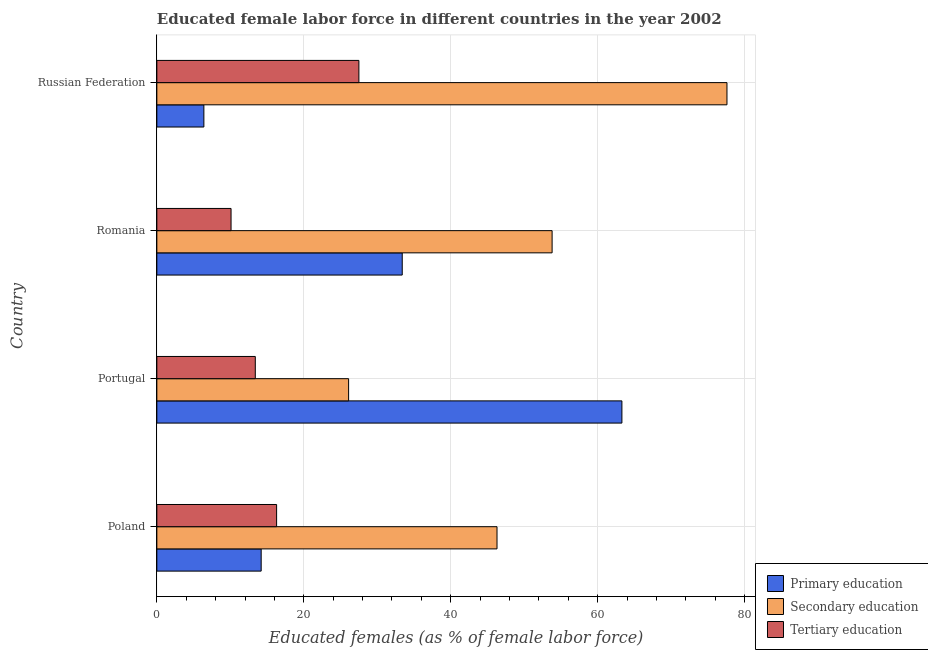What is the label of the 3rd group of bars from the top?
Give a very brief answer. Portugal. What is the percentage of female labor force who received primary education in Romania?
Provide a succinct answer. 33.4. Across all countries, what is the maximum percentage of female labor force who received primary education?
Provide a short and direct response. 63.3. Across all countries, what is the minimum percentage of female labor force who received secondary education?
Keep it short and to the point. 26.1. In which country was the percentage of female labor force who received tertiary education maximum?
Ensure brevity in your answer.  Russian Federation. In which country was the percentage of female labor force who received tertiary education minimum?
Keep it short and to the point. Romania. What is the total percentage of female labor force who received tertiary education in the graph?
Keep it short and to the point. 67.3. What is the difference between the percentage of female labor force who received secondary education in Romania and that in Russian Federation?
Provide a short and direct response. -23.8. What is the difference between the percentage of female labor force who received primary education in Russian Federation and the percentage of female labor force who received tertiary education in Portugal?
Your response must be concise. -7. What is the average percentage of female labor force who received tertiary education per country?
Ensure brevity in your answer.  16.82. What is the difference between the percentage of female labor force who received secondary education and percentage of female labor force who received tertiary education in Russian Federation?
Your answer should be very brief. 50.1. In how many countries, is the percentage of female labor force who received tertiary education greater than 24 %?
Offer a very short reply. 1. What is the ratio of the percentage of female labor force who received primary education in Poland to that in Romania?
Your response must be concise. 0.42. Is the difference between the percentage of female labor force who received primary education in Portugal and Romania greater than the difference between the percentage of female labor force who received secondary education in Portugal and Romania?
Give a very brief answer. Yes. What is the difference between the highest and the second highest percentage of female labor force who received secondary education?
Keep it short and to the point. 23.8. What is the difference between the highest and the lowest percentage of female labor force who received secondary education?
Keep it short and to the point. 51.5. Is the sum of the percentage of female labor force who received primary education in Portugal and Romania greater than the maximum percentage of female labor force who received secondary education across all countries?
Give a very brief answer. Yes. What does the 1st bar from the top in Poland represents?
Give a very brief answer. Tertiary education. What does the 1st bar from the bottom in Russian Federation represents?
Provide a short and direct response. Primary education. Is it the case that in every country, the sum of the percentage of female labor force who received primary education and percentage of female labor force who received secondary education is greater than the percentage of female labor force who received tertiary education?
Provide a succinct answer. Yes. What is the difference between two consecutive major ticks on the X-axis?
Provide a succinct answer. 20. Are the values on the major ticks of X-axis written in scientific E-notation?
Your response must be concise. No. Does the graph contain grids?
Give a very brief answer. Yes. How many legend labels are there?
Provide a succinct answer. 3. How are the legend labels stacked?
Give a very brief answer. Vertical. What is the title of the graph?
Your response must be concise. Educated female labor force in different countries in the year 2002. What is the label or title of the X-axis?
Ensure brevity in your answer.  Educated females (as % of female labor force). What is the label or title of the Y-axis?
Provide a short and direct response. Country. What is the Educated females (as % of female labor force) in Primary education in Poland?
Ensure brevity in your answer.  14.2. What is the Educated females (as % of female labor force) in Secondary education in Poland?
Ensure brevity in your answer.  46.3. What is the Educated females (as % of female labor force) in Tertiary education in Poland?
Your answer should be compact. 16.3. What is the Educated females (as % of female labor force) in Primary education in Portugal?
Give a very brief answer. 63.3. What is the Educated females (as % of female labor force) of Secondary education in Portugal?
Offer a terse response. 26.1. What is the Educated females (as % of female labor force) of Tertiary education in Portugal?
Offer a terse response. 13.4. What is the Educated females (as % of female labor force) in Primary education in Romania?
Offer a very short reply. 33.4. What is the Educated females (as % of female labor force) in Secondary education in Romania?
Ensure brevity in your answer.  53.8. What is the Educated females (as % of female labor force) in Tertiary education in Romania?
Provide a short and direct response. 10.1. What is the Educated females (as % of female labor force) in Primary education in Russian Federation?
Provide a succinct answer. 6.4. What is the Educated females (as % of female labor force) in Secondary education in Russian Federation?
Your answer should be very brief. 77.6. What is the Educated females (as % of female labor force) of Tertiary education in Russian Federation?
Give a very brief answer. 27.5. Across all countries, what is the maximum Educated females (as % of female labor force) in Primary education?
Ensure brevity in your answer.  63.3. Across all countries, what is the maximum Educated females (as % of female labor force) of Secondary education?
Make the answer very short. 77.6. Across all countries, what is the minimum Educated females (as % of female labor force) in Primary education?
Keep it short and to the point. 6.4. Across all countries, what is the minimum Educated females (as % of female labor force) of Secondary education?
Your answer should be compact. 26.1. Across all countries, what is the minimum Educated females (as % of female labor force) in Tertiary education?
Ensure brevity in your answer.  10.1. What is the total Educated females (as % of female labor force) in Primary education in the graph?
Ensure brevity in your answer.  117.3. What is the total Educated females (as % of female labor force) in Secondary education in the graph?
Provide a succinct answer. 203.8. What is the total Educated females (as % of female labor force) of Tertiary education in the graph?
Give a very brief answer. 67.3. What is the difference between the Educated females (as % of female labor force) in Primary education in Poland and that in Portugal?
Offer a very short reply. -49.1. What is the difference between the Educated females (as % of female labor force) of Secondary education in Poland and that in Portugal?
Your answer should be very brief. 20.2. What is the difference between the Educated females (as % of female labor force) of Primary education in Poland and that in Romania?
Keep it short and to the point. -19.2. What is the difference between the Educated females (as % of female labor force) of Secondary education in Poland and that in Romania?
Give a very brief answer. -7.5. What is the difference between the Educated females (as % of female labor force) in Tertiary education in Poland and that in Romania?
Your answer should be very brief. 6.2. What is the difference between the Educated females (as % of female labor force) in Secondary education in Poland and that in Russian Federation?
Offer a very short reply. -31.3. What is the difference between the Educated females (as % of female labor force) of Primary education in Portugal and that in Romania?
Offer a terse response. 29.9. What is the difference between the Educated females (as % of female labor force) of Secondary education in Portugal and that in Romania?
Provide a short and direct response. -27.7. What is the difference between the Educated females (as % of female labor force) of Primary education in Portugal and that in Russian Federation?
Make the answer very short. 56.9. What is the difference between the Educated females (as % of female labor force) in Secondary education in Portugal and that in Russian Federation?
Keep it short and to the point. -51.5. What is the difference between the Educated females (as % of female labor force) of Tertiary education in Portugal and that in Russian Federation?
Ensure brevity in your answer.  -14.1. What is the difference between the Educated females (as % of female labor force) in Primary education in Romania and that in Russian Federation?
Give a very brief answer. 27. What is the difference between the Educated females (as % of female labor force) in Secondary education in Romania and that in Russian Federation?
Provide a short and direct response. -23.8. What is the difference between the Educated females (as % of female labor force) in Tertiary education in Romania and that in Russian Federation?
Ensure brevity in your answer.  -17.4. What is the difference between the Educated females (as % of female labor force) in Primary education in Poland and the Educated females (as % of female labor force) in Tertiary education in Portugal?
Your response must be concise. 0.8. What is the difference between the Educated females (as % of female labor force) in Secondary education in Poland and the Educated females (as % of female labor force) in Tertiary education in Portugal?
Give a very brief answer. 32.9. What is the difference between the Educated females (as % of female labor force) of Primary education in Poland and the Educated females (as % of female labor force) of Secondary education in Romania?
Your answer should be very brief. -39.6. What is the difference between the Educated females (as % of female labor force) in Primary education in Poland and the Educated females (as % of female labor force) in Tertiary education in Romania?
Keep it short and to the point. 4.1. What is the difference between the Educated females (as % of female labor force) of Secondary education in Poland and the Educated females (as % of female labor force) of Tertiary education in Romania?
Provide a short and direct response. 36.2. What is the difference between the Educated females (as % of female labor force) of Primary education in Poland and the Educated females (as % of female labor force) of Secondary education in Russian Federation?
Your answer should be compact. -63.4. What is the difference between the Educated females (as % of female labor force) in Secondary education in Poland and the Educated females (as % of female labor force) in Tertiary education in Russian Federation?
Give a very brief answer. 18.8. What is the difference between the Educated females (as % of female labor force) in Primary education in Portugal and the Educated females (as % of female labor force) in Secondary education in Romania?
Your answer should be very brief. 9.5. What is the difference between the Educated females (as % of female labor force) of Primary education in Portugal and the Educated females (as % of female labor force) of Tertiary education in Romania?
Ensure brevity in your answer.  53.2. What is the difference between the Educated females (as % of female labor force) in Primary education in Portugal and the Educated females (as % of female labor force) in Secondary education in Russian Federation?
Make the answer very short. -14.3. What is the difference between the Educated females (as % of female labor force) of Primary education in Portugal and the Educated females (as % of female labor force) of Tertiary education in Russian Federation?
Keep it short and to the point. 35.8. What is the difference between the Educated females (as % of female labor force) in Primary education in Romania and the Educated females (as % of female labor force) in Secondary education in Russian Federation?
Provide a succinct answer. -44.2. What is the difference between the Educated females (as % of female labor force) in Primary education in Romania and the Educated females (as % of female labor force) in Tertiary education in Russian Federation?
Your response must be concise. 5.9. What is the difference between the Educated females (as % of female labor force) of Secondary education in Romania and the Educated females (as % of female labor force) of Tertiary education in Russian Federation?
Your answer should be compact. 26.3. What is the average Educated females (as % of female labor force) of Primary education per country?
Give a very brief answer. 29.32. What is the average Educated females (as % of female labor force) in Secondary education per country?
Offer a terse response. 50.95. What is the average Educated females (as % of female labor force) of Tertiary education per country?
Provide a short and direct response. 16.82. What is the difference between the Educated females (as % of female labor force) of Primary education and Educated females (as % of female labor force) of Secondary education in Poland?
Offer a terse response. -32.1. What is the difference between the Educated females (as % of female labor force) of Primary education and Educated females (as % of female labor force) of Secondary education in Portugal?
Offer a very short reply. 37.2. What is the difference between the Educated females (as % of female labor force) in Primary education and Educated females (as % of female labor force) in Tertiary education in Portugal?
Give a very brief answer. 49.9. What is the difference between the Educated females (as % of female labor force) in Secondary education and Educated females (as % of female labor force) in Tertiary education in Portugal?
Give a very brief answer. 12.7. What is the difference between the Educated females (as % of female labor force) in Primary education and Educated females (as % of female labor force) in Secondary education in Romania?
Provide a succinct answer. -20.4. What is the difference between the Educated females (as % of female labor force) of Primary education and Educated females (as % of female labor force) of Tertiary education in Romania?
Your response must be concise. 23.3. What is the difference between the Educated females (as % of female labor force) of Secondary education and Educated females (as % of female labor force) of Tertiary education in Romania?
Ensure brevity in your answer.  43.7. What is the difference between the Educated females (as % of female labor force) in Primary education and Educated females (as % of female labor force) in Secondary education in Russian Federation?
Offer a terse response. -71.2. What is the difference between the Educated females (as % of female labor force) in Primary education and Educated females (as % of female labor force) in Tertiary education in Russian Federation?
Your response must be concise. -21.1. What is the difference between the Educated females (as % of female labor force) in Secondary education and Educated females (as % of female labor force) in Tertiary education in Russian Federation?
Your answer should be compact. 50.1. What is the ratio of the Educated females (as % of female labor force) in Primary education in Poland to that in Portugal?
Give a very brief answer. 0.22. What is the ratio of the Educated females (as % of female labor force) of Secondary education in Poland to that in Portugal?
Offer a terse response. 1.77. What is the ratio of the Educated females (as % of female labor force) of Tertiary education in Poland to that in Portugal?
Your response must be concise. 1.22. What is the ratio of the Educated females (as % of female labor force) of Primary education in Poland to that in Romania?
Ensure brevity in your answer.  0.43. What is the ratio of the Educated females (as % of female labor force) in Secondary education in Poland to that in Romania?
Offer a terse response. 0.86. What is the ratio of the Educated females (as % of female labor force) of Tertiary education in Poland to that in Romania?
Offer a terse response. 1.61. What is the ratio of the Educated females (as % of female labor force) of Primary education in Poland to that in Russian Federation?
Provide a succinct answer. 2.22. What is the ratio of the Educated females (as % of female labor force) in Secondary education in Poland to that in Russian Federation?
Offer a very short reply. 0.6. What is the ratio of the Educated females (as % of female labor force) of Tertiary education in Poland to that in Russian Federation?
Provide a succinct answer. 0.59. What is the ratio of the Educated females (as % of female labor force) of Primary education in Portugal to that in Romania?
Your answer should be compact. 1.9. What is the ratio of the Educated females (as % of female labor force) of Secondary education in Portugal to that in Romania?
Ensure brevity in your answer.  0.49. What is the ratio of the Educated females (as % of female labor force) in Tertiary education in Portugal to that in Romania?
Give a very brief answer. 1.33. What is the ratio of the Educated females (as % of female labor force) of Primary education in Portugal to that in Russian Federation?
Your answer should be very brief. 9.89. What is the ratio of the Educated females (as % of female labor force) of Secondary education in Portugal to that in Russian Federation?
Your answer should be compact. 0.34. What is the ratio of the Educated females (as % of female labor force) in Tertiary education in Portugal to that in Russian Federation?
Your response must be concise. 0.49. What is the ratio of the Educated females (as % of female labor force) in Primary education in Romania to that in Russian Federation?
Ensure brevity in your answer.  5.22. What is the ratio of the Educated females (as % of female labor force) in Secondary education in Romania to that in Russian Federation?
Provide a succinct answer. 0.69. What is the ratio of the Educated females (as % of female labor force) in Tertiary education in Romania to that in Russian Federation?
Your answer should be compact. 0.37. What is the difference between the highest and the second highest Educated females (as % of female labor force) in Primary education?
Keep it short and to the point. 29.9. What is the difference between the highest and the second highest Educated females (as % of female labor force) of Secondary education?
Your response must be concise. 23.8. What is the difference between the highest and the lowest Educated females (as % of female labor force) of Primary education?
Your answer should be very brief. 56.9. What is the difference between the highest and the lowest Educated females (as % of female labor force) of Secondary education?
Ensure brevity in your answer.  51.5. 